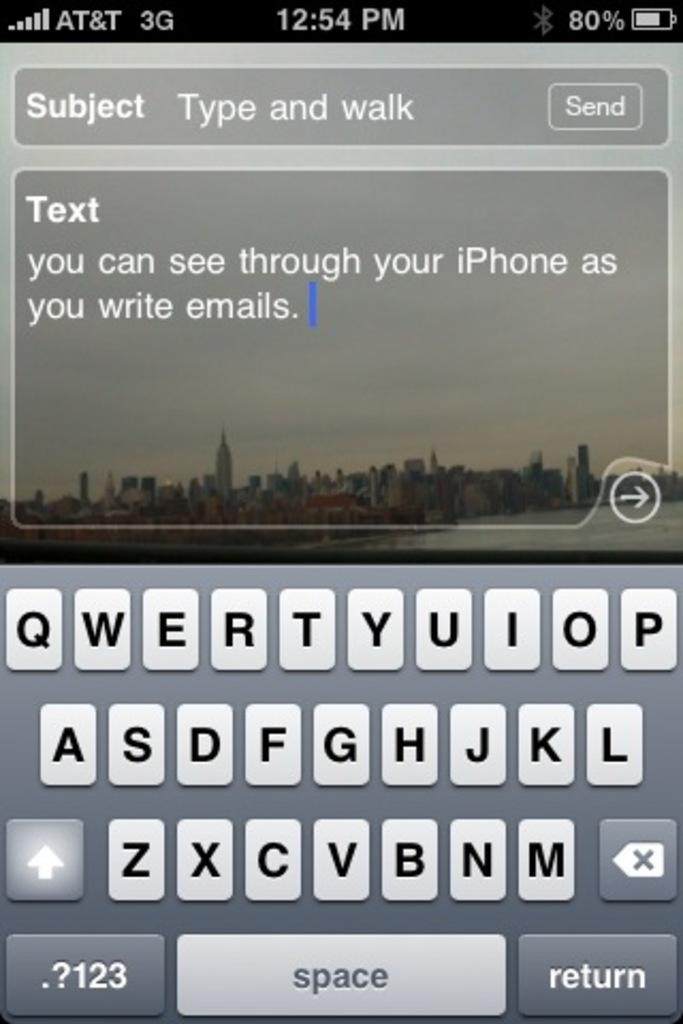What's the message subject?
Ensure brevity in your answer.  Type and walk. 